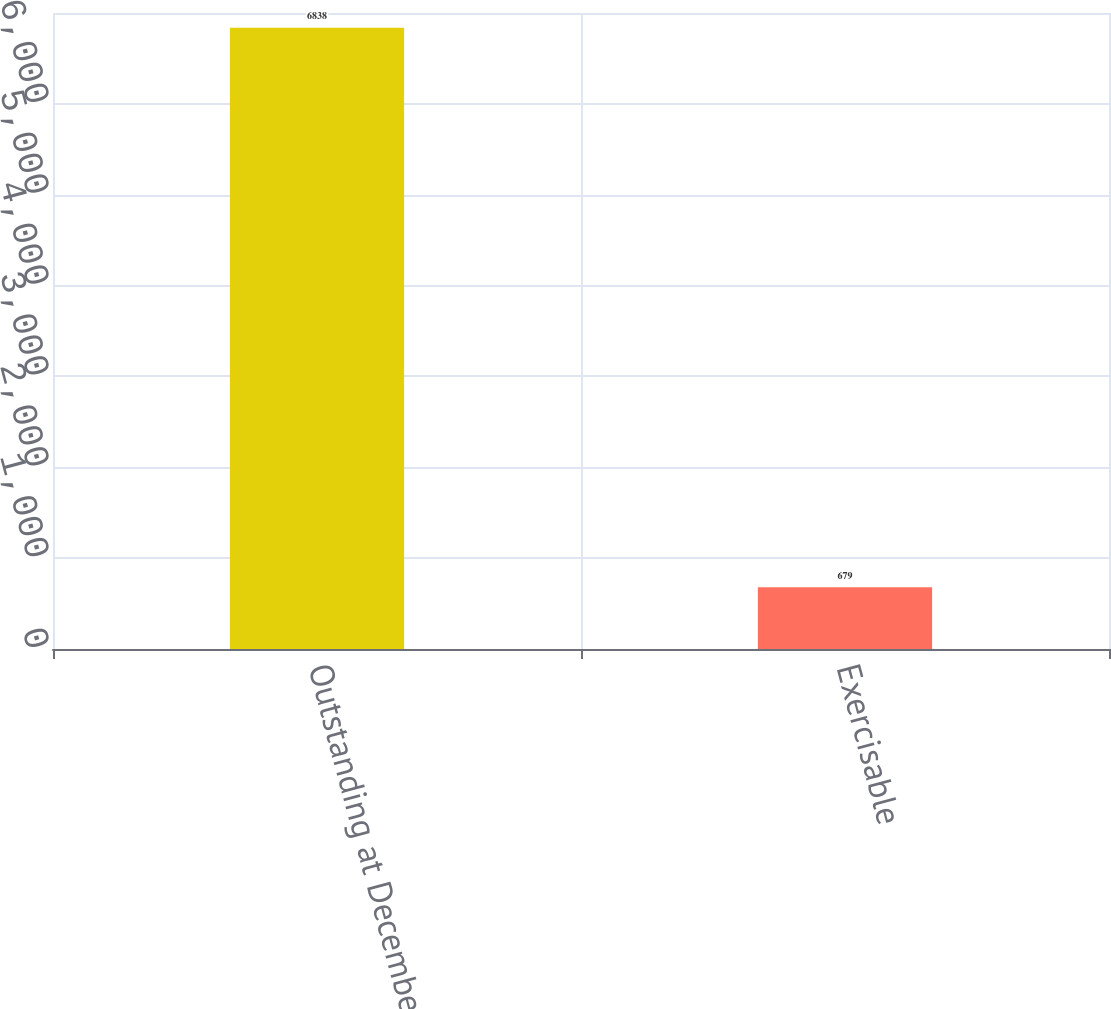Convert chart to OTSL. <chart><loc_0><loc_0><loc_500><loc_500><bar_chart><fcel>Outstanding at December 31<fcel>Exercisable<nl><fcel>6838<fcel>679<nl></chart> 